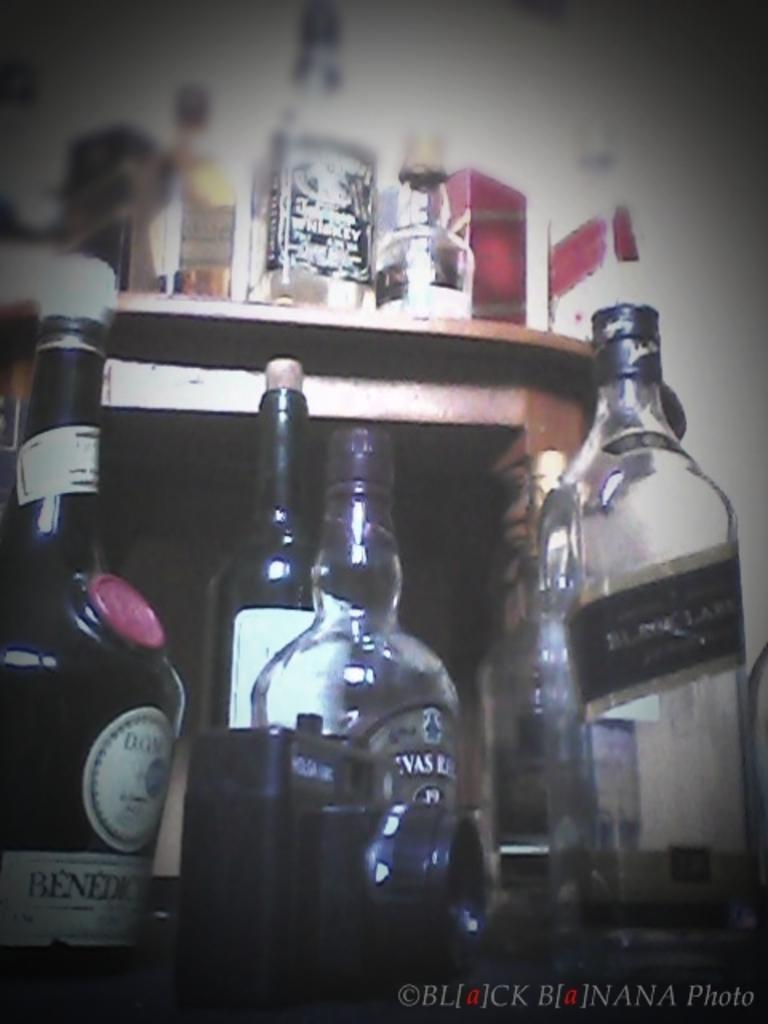What type of bottles are on the floor in the image? There are wine bottles on the floor. What type of furniture is present in the image? There is a wooden table in the image. What is on the wooden table? There are wine bottles on the wooden table. How many bushes are visible in the image? There are no bushes visible in the image; it only features wine bottles on the floor and on a wooden table. 